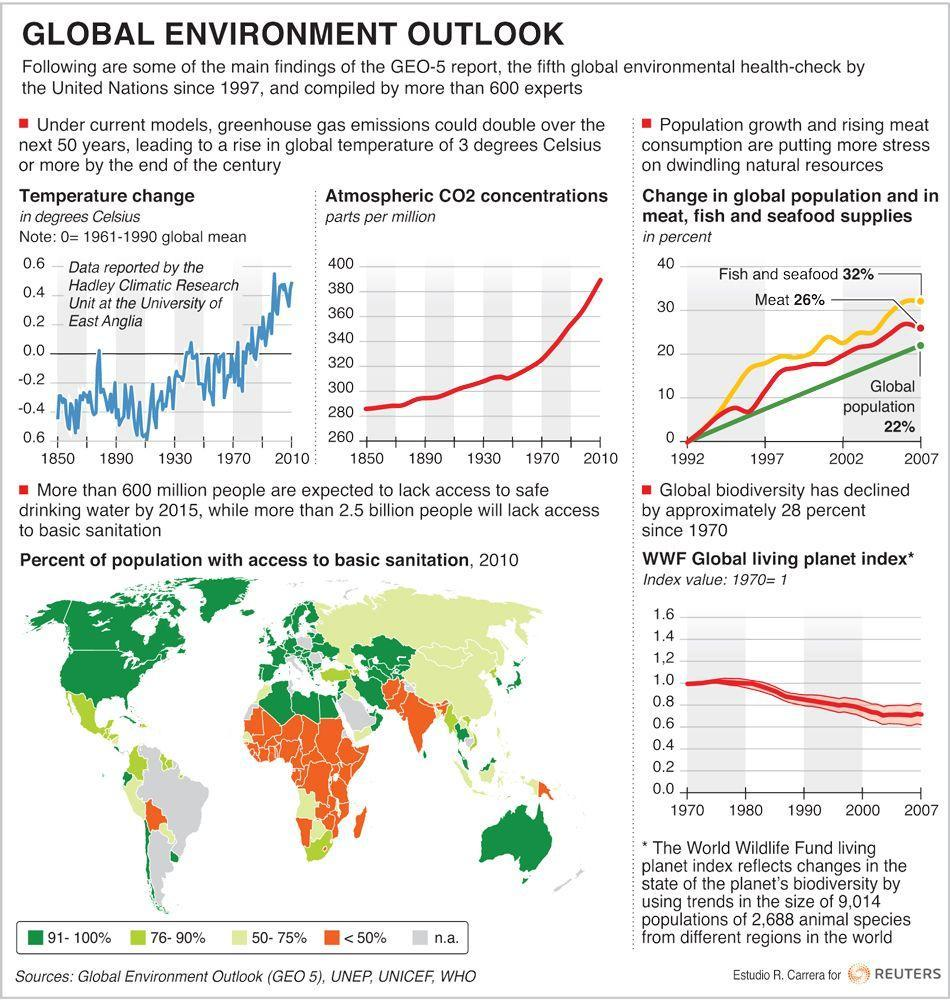What was the change in meat supplies (in percent) in 2002?
Answer the question with a short phrase. 20% What is the atmospheric CO2 concentration (in parts per million) for the year 2010? 390 In 2010, what percent of population in USA had access to basic sanitation? 91-100% In 2010, what percent of population in India had access to basic sanitation? <50% What is the atmospheric CO2 concentration (in parts per million) for the year 1910? 300 